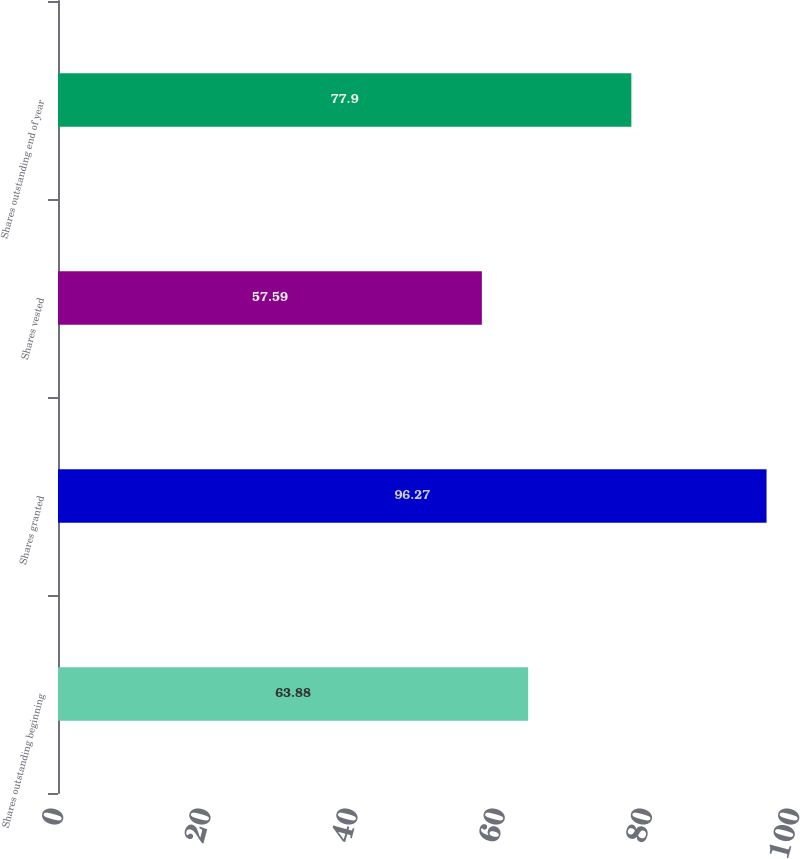<chart> <loc_0><loc_0><loc_500><loc_500><bar_chart><fcel>Shares outstanding beginning<fcel>Shares granted<fcel>Shares vested<fcel>Shares outstanding end of year<nl><fcel>63.88<fcel>96.27<fcel>57.59<fcel>77.9<nl></chart> 